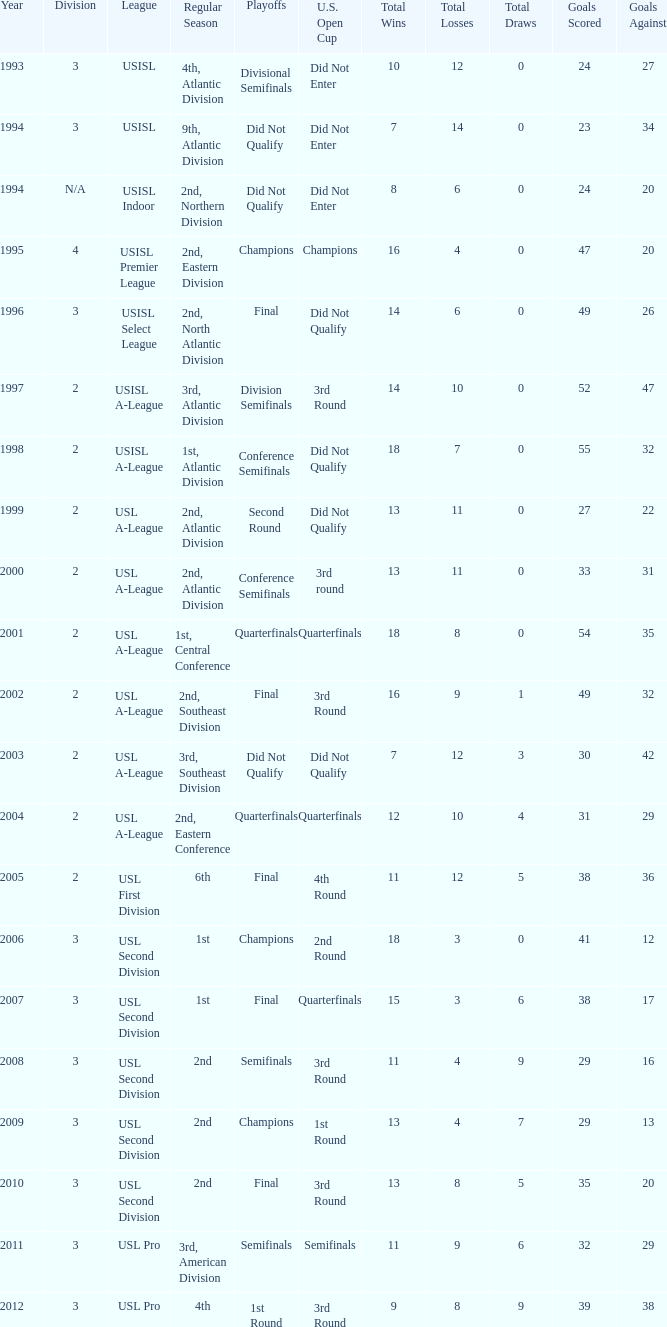Which round is u.s. open cup division semifinals 3rd Round. 